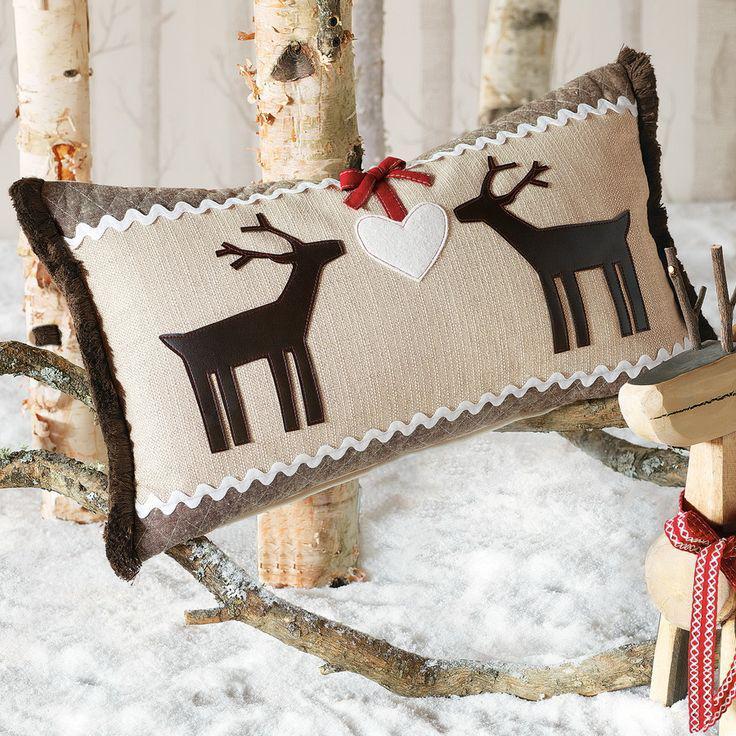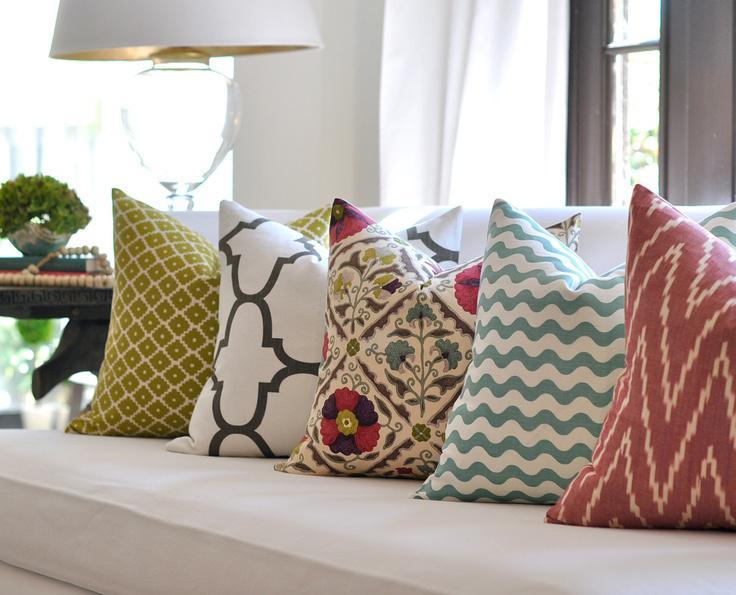The first image is the image on the left, the second image is the image on the right. Assess this claim about the two images: "One image includes at least one pillow decorated with animal silhouettes.". Correct or not? Answer yes or no. Yes. The first image is the image on the left, the second image is the image on the right. Evaluate the accuracy of this statement regarding the images: "All images appear to be couches.". Is it true? Answer yes or no. No. 